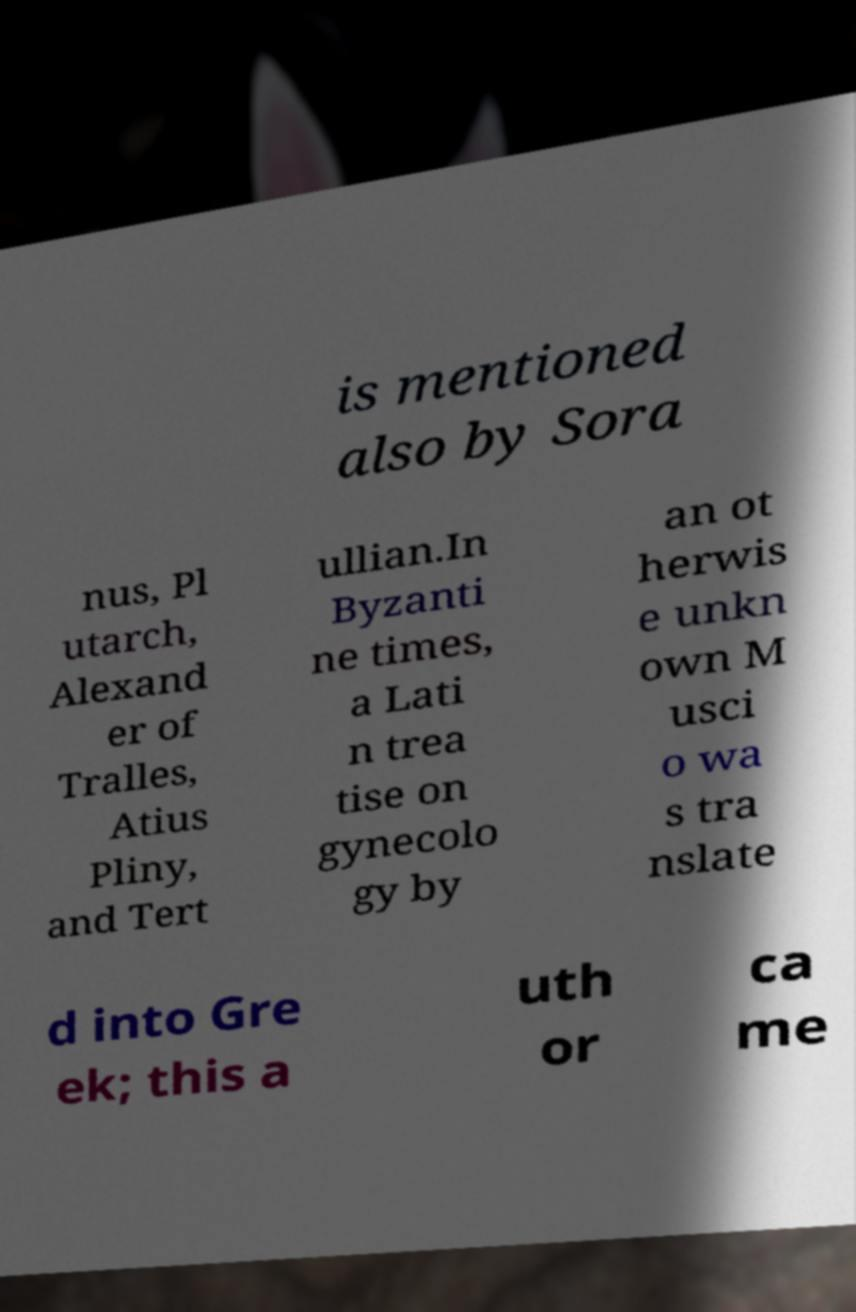There's text embedded in this image that I need extracted. Can you transcribe it verbatim? is mentioned also by Sora nus, Pl utarch, Alexand er of Tralles, Atius Pliny, and Tert ullian.In Byzanti ne times, a Lati n trea tise on gynecolo gy by an ot herwis e unkn own M usci o wa s tra nslate d into Gre ek; this a uth or ca me 